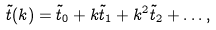<formula> <loc_0><loc_0><loc_500><loc_500>\tilde { t } ( k ) = \tilde { t } _ { 0 } + k \tilde { t } _ { 1 } + k ^ { 2 } \tilde { t } _ { 2 } + \dots ,</formula> 